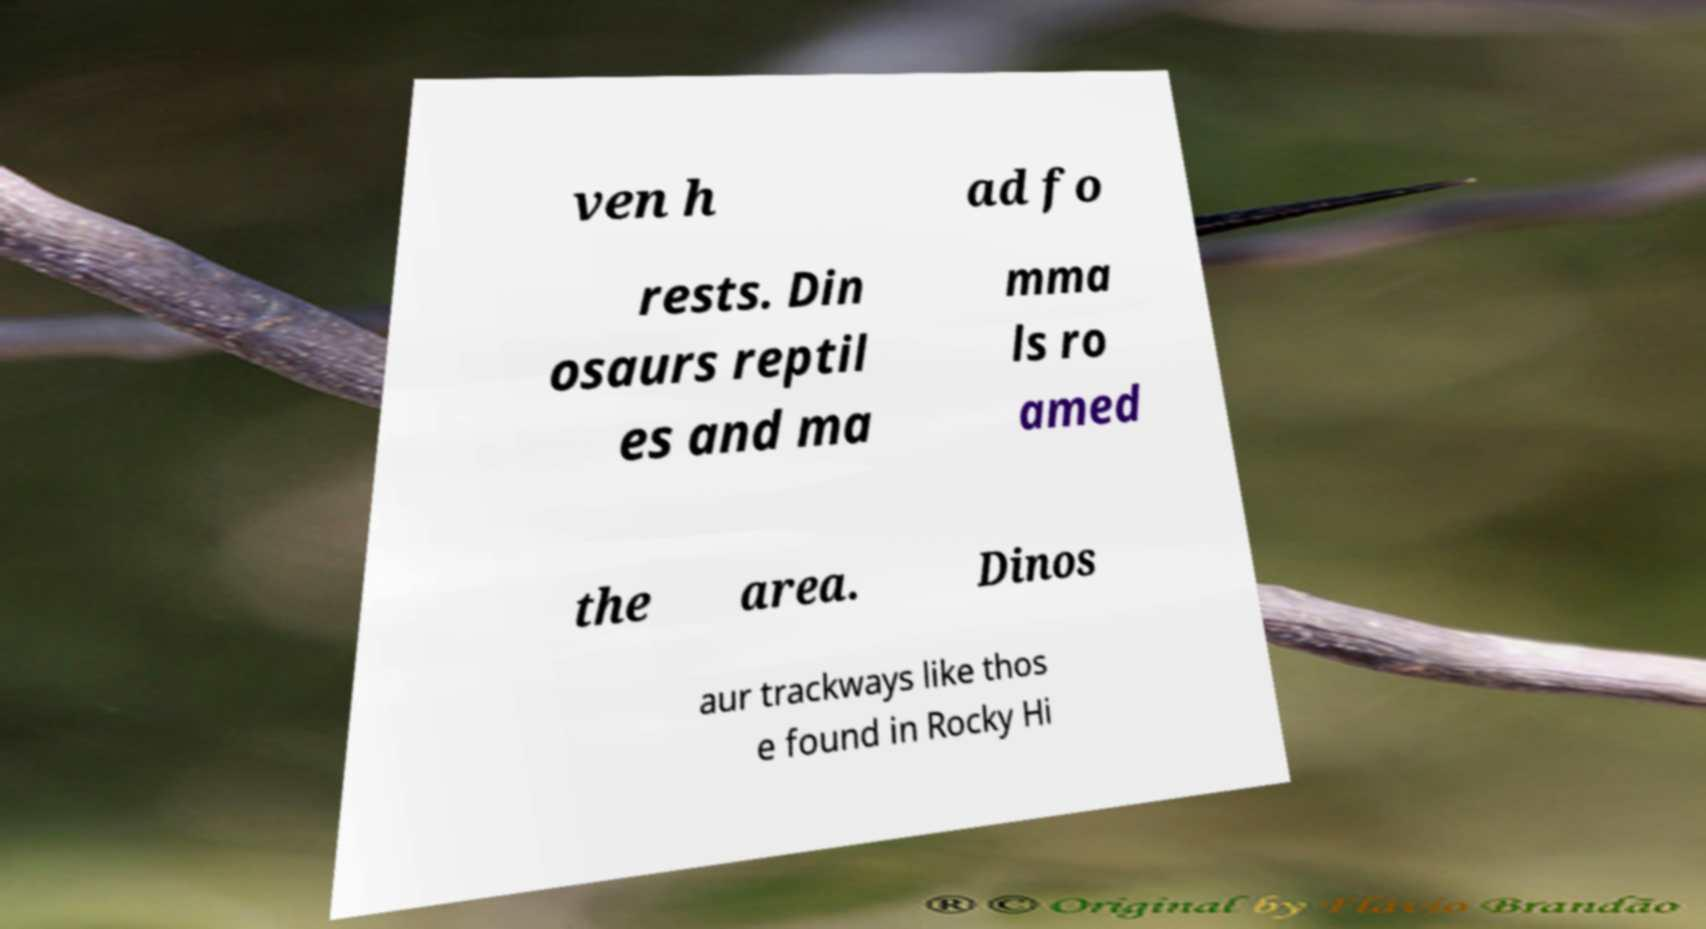What messages or text are displayed in this image? I need them in a readable, typed format. ven h ad fo rests. Din osaurs reptil es and ma mma ls ro amed the area. Dinos aur trackways like thos e found in Rocky Hi 